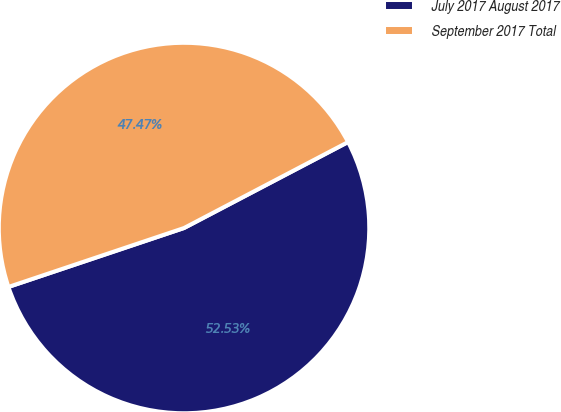Convert chart to OTSL. <chart><loc_0><loc_0><loc_500><loc_500><pie_chart><fcel>July 2017 August 2017<fcel>September 2017 Total<nl><fcel>52.53%<fcel>47.47%<nl></chart> 